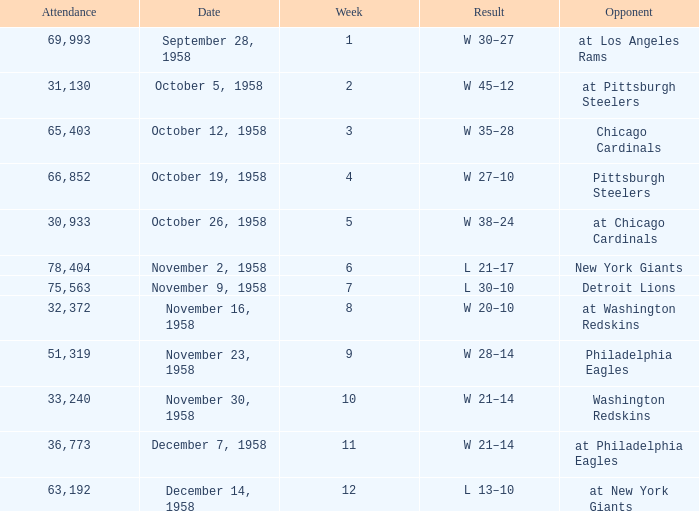What day had over 51,319 attending week 4? October 19, 1958. I'm looking to parse the entire table for insights. Could you assist me with that? {'header': ['Attendance', 'Date', 'Week', 'Result', 'Opponent'], 'rows': [['69,993', 'September 28, 1958', '1', 'W 30–27', 'at Los Angeles Rams'], ['31,130', 'October 5, 1958', '2', 'W 45–12', 'at Pittsburgh Steelers'], ['65,403', 'October 12, 1958', '3', 'W 35–28', 'Chicago Cardinals'], ['66,852', 'October 19, 1958', '4', 'W 27–10', 'Pittsburgh Steelers'], ['30,933', 'October 26, 1958', '5', 'W 38–24', 'at Chicago Cardinals'], ['78,404', 'November 2, 1958', '6', 'L 21–17', 'New York Giants'], ['75,563', 'November 9, 1958', '7', 'L 30–10', 'Detroit Lions'], ['32,372', 'November 16, 1958', '8', 'W 20–10', 'at Washington Redskins'], ['51,319', 'November 23, 1958', '9', 'W 28–14', 'Philadelphia Eagles'], ['33,240', 'November 30, 1958', '10', 'W 21–14', 'Washington Redskins'], ['36,773', 'December 7, 1958', '11', 'W 21–14', 'at Philadelphia Eagles'], ['63,192', 'December 14, 1958', '12', 'L 13–10', 'at New York Giants']]} 